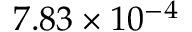Convert formula to latex. <formula><loc_0><loc_0><loc_500><loc_500>7 . 8 3 \times 1 0 ^ { - 4 }</formula> 